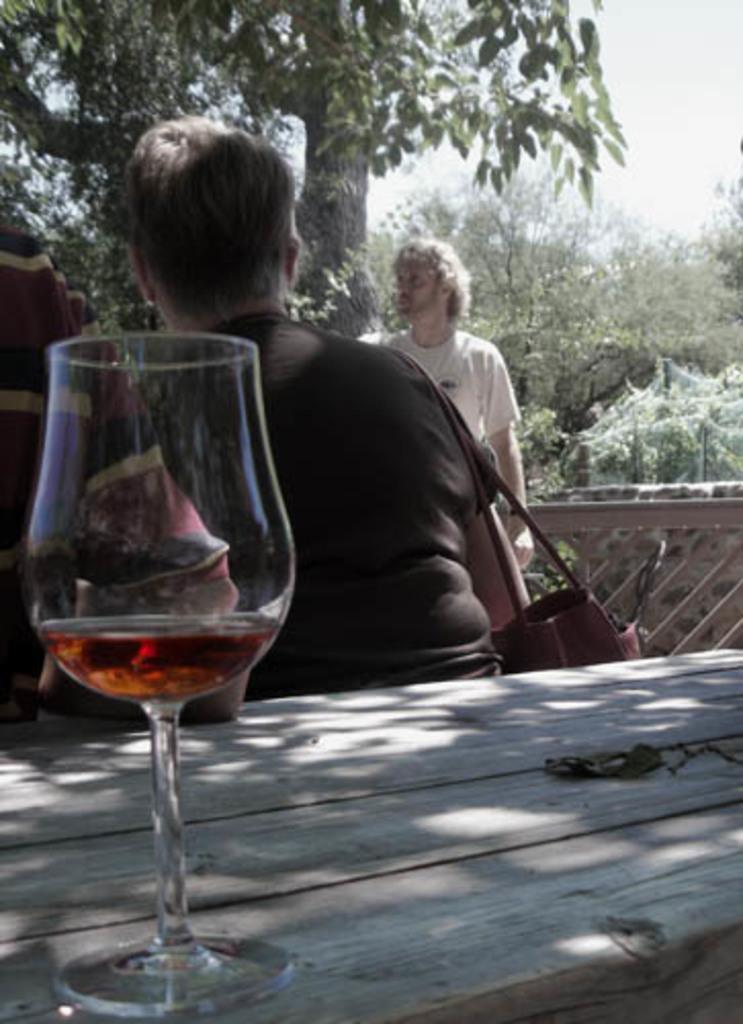In one or two sentences, can you explain what this image depicts? In this picture we can see a glass on the table. Here we can see two persons. He is carrying his bag. On the background we can see some trees. And this is sky. 